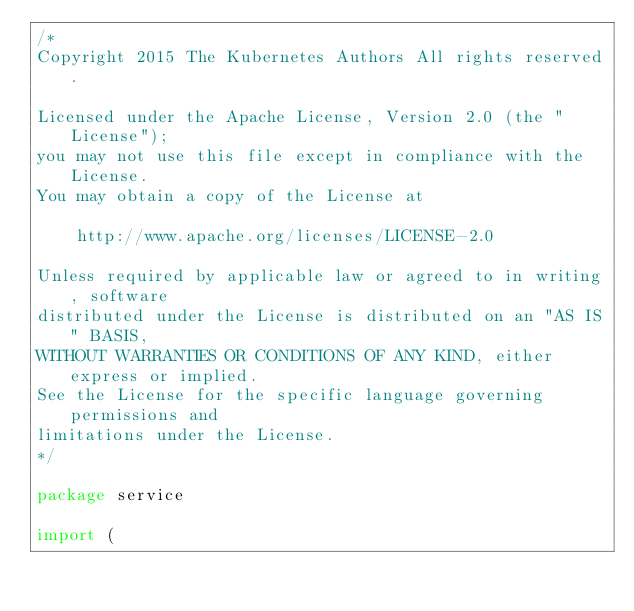<code> <loc_0><loc_0><loc_500><loc_500><_Go_>/*
Copyright 2015 The Kubernetes Authors All rights reserved.

Licensed under the Apache License, Version 2.0 (the "License");
you may not use this file except in compliance with the License.
You may obtain a copy of the License at

    http://www.apache.org/licenses/LICENSE-2.0

Unless required by applicable law or agreed to in writing, software
distributed under the License is distributed on an "AS IS" BASIS,
WITHOUT WARRANTIES OR CONDITIONS OF ANY KIND, either express or implied.
See the License for the specific language governing permissions and
limitations under the License.
*/

package service

import (</code> 